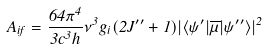<formula> <loc_0><loc_0><loc_500><loc_500>A _ { i f } = \frac { 6 4 \pi ^ { 4 } } { 3 c ^ { 3 } h } \nu ^ { 3 } g _ { i } ( 2 J ^ { \prime \prime } + 1 ) | \langle \psi ^ { \prime } | \overline { \mu } | \psi ^ { \prime \prime } \rangle | ^ { 2 }</formula> 